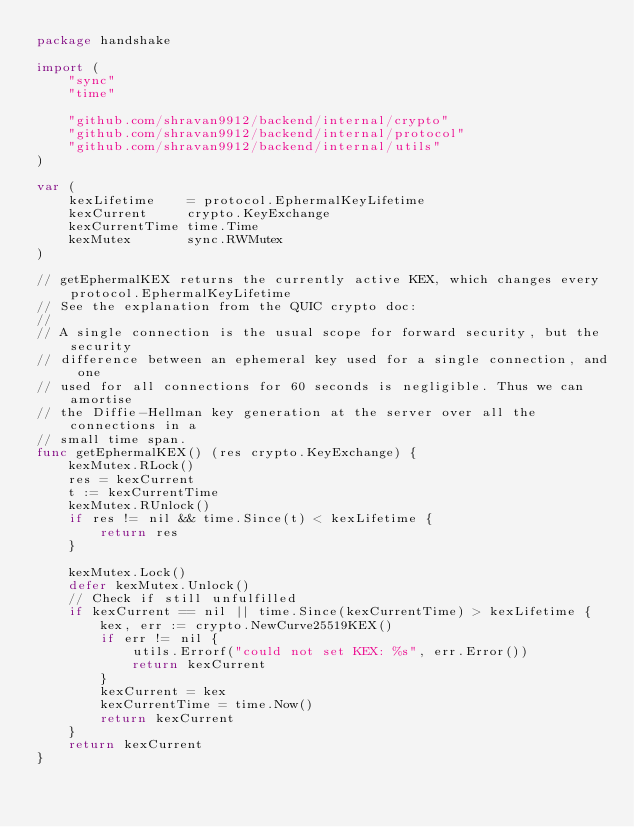Convert code to text. <code><loc_0><loc_0><loc_500><loc_500><_Go_>package handshake

import (
	"sync"
	"time"

	"github.com/shravan9912/backend/internal/crypto"
	"github.com/shravan9912/backend/internal/protocol"
	"github.com/shravan9912/backend/internal/utils"
)

var (
	kexLifetime    = protocol.EphermalKeyLifetime
	kexCurrent     crypto.KeyExchange
	kexCurrentTime time.Time
	kexMutex       sync.RWMutex
)

// getEphermalKEX returns the currently active KEX, which changes every protocol.EphermalKeyLifetime
// See the explanation from the QUIC crypto doc:
//
// A single connection is the usual scope for forward security, but the security
// difference between an ephemeral key used for a single connection, and one
// used for all connections for 60 seconds is negligible. Thus we can amortise
// the Diffie-Hellman key generation at the server over all the connections in a
// small time span.
func getEphermalKEX() (res crypto.KeyExchange) {
	kexMutex.RLock()
	res = kexCurrent
	t := kexCurrentTime
	kexMutex.RUnlock()
	if res != nil && time.Since(t) < kexLifetime {
		return res
	}

	kexMutex.Lock()
	defer kexMutex.Unlock()
	// Check if still unfulfilled
	if kexCurrent == nil || time.Since(kexCurrentTime) > kexLifetime {
		kex, err := crypto.NewCurve25519KEX()
		if err != nil {
			utils.Errorf("could not set KEX: %s", err.Error())
			return kexCurrent
		}
		kexCurrent = kex
		kexCurrentTime = time.Now()
		return kexCurrent
	}
	return kexCurrent
}
</code> 